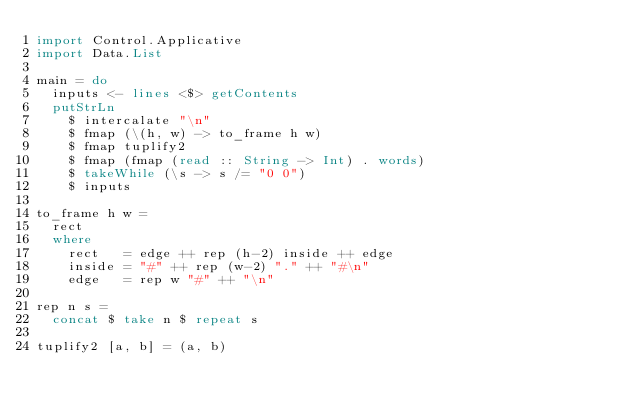Convert code to text. <code><loc_0><loc_0><loc_500><loc_500><_Haskell_>import Control.Applicative
import Data.List

main = do
  inputs <- lines <$> getContents
  putStrLn
    $ intercalate "\n"
    $ fmap (\(h, w) -> to_frame h w)
    $ fmap tuplify2
    $ fmap (fmap (read :: String -> Int) . words)
    $ takeWhile (\s -> s /= "0 0")
    $ inputs

to_frame h w =
  rect
  where
    rect   = edge ++ rep (h-2) inside ++ edge
    inside = "#" ++ rep (w-2) "." ++ "#\n"
    edge   = rep w "#" ++ "\n"

rep n s =
  concat $ take n $ repeat s

tuplify2 [a, b] = (a, b)</code> 